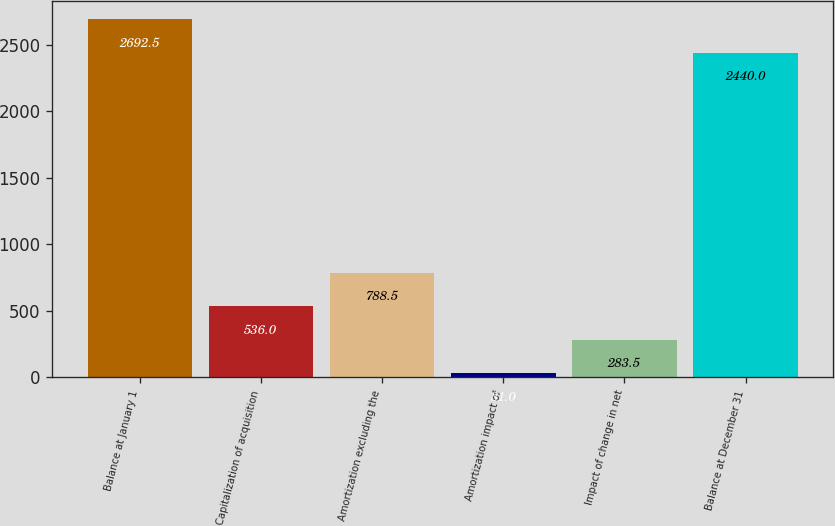Convert chart. <chart><loc_0><loc_0><loc_500><loc_500><bar_chart><fcel>Balance at January 1<fcel>Capitalization of acquisition<fcel>Amortization excluding the<fcel>Amortization impact of<fcel>Impact of change in net<fcel>Balance at December 31<nl><fcel>2692.5<fcel>536<fcel>788.5<fcel>31<fcel>283.5<fcel>2440<nl></chart> 